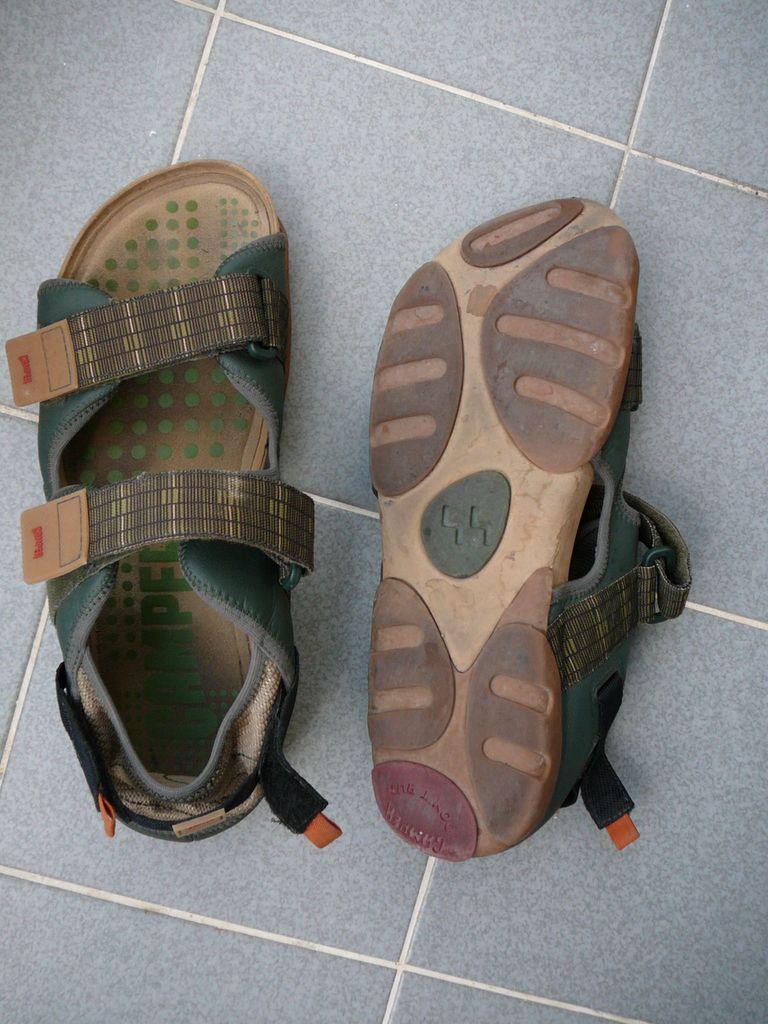Could you give a brief overview of what you see in this image? In this image there are two sandals on the ground. The sandal on the left side is in upward direction and while the sandal on right side is in reverse direction. 